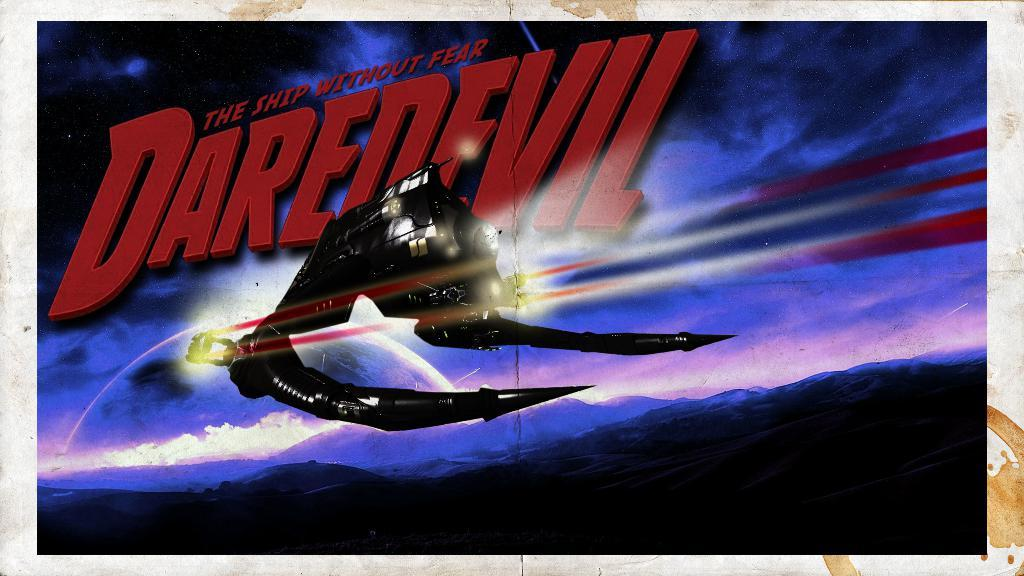What type of visual representation is the image? The image is a poster. What geographical feature is depicted in the poster? There are mountains depicted in the poster. What else can be found on the poster besides the mountains? There is text present in the poster. What kind of image is animated in the poster? There is an animated image in the poster. Where is the table located in the poster? There is no table present in the poster. What type of coach can be seen in the poster? There is no coach present in the poster. 